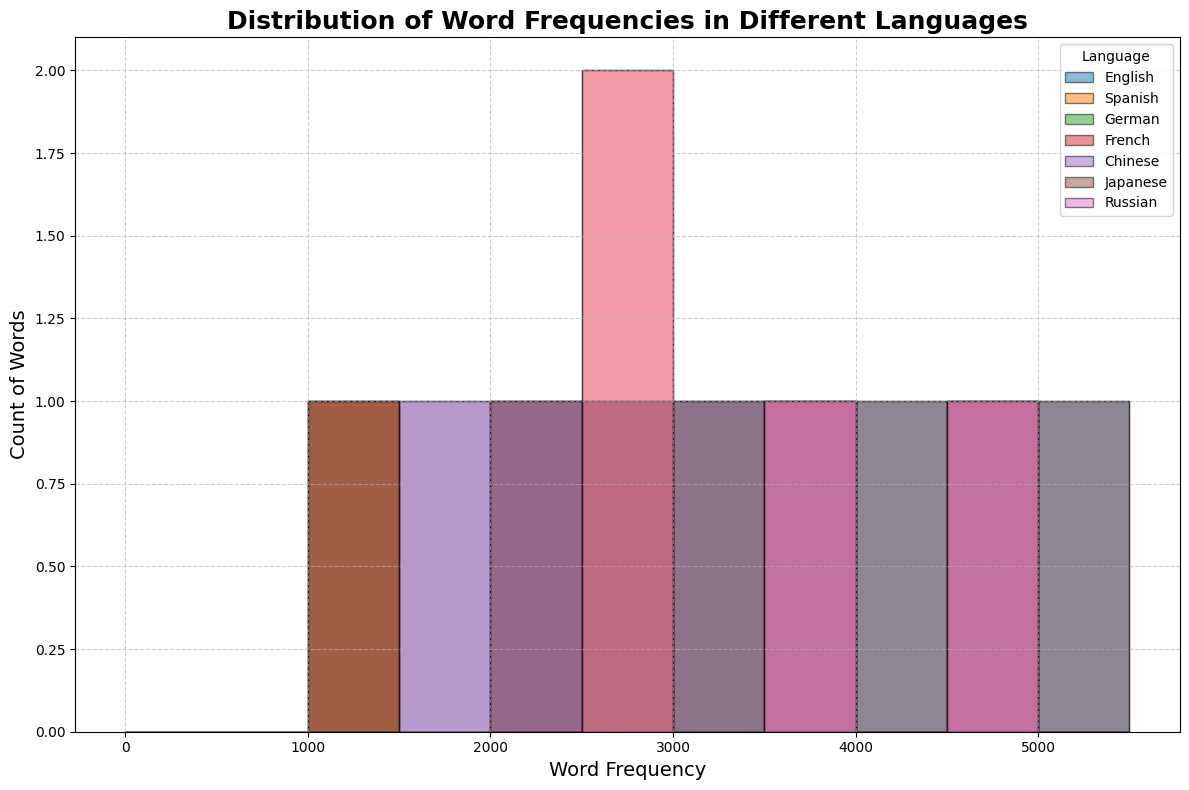Which language has the highest word frequency count in the dataset? By looking at the histogram, find the language with the tallest bar, indicating the highest total word frequency count.
Answer: Chinese How does the word frequency distribution in Japanese compare to that in English? Compare the height and spread of the histogram bars for Japanese and English. Ensure to note which language has more words in higher frequency ranges.
Answer: Japanese has higher frequency words than English Which language displays the widest range of word frequencies? Identify the language whose histogram bars stretch over the widest range of word frequencies.
Answer: Chinese Are there any languages with a similar word frequency range? Compare the histograms and find any languages that have overlapping frequency ranges and similar heights.
Answer: German and French have similar ranges Which language has the most words with a frequency over 5000? Count the number of bars representing words with frequencies greater than 5000 for each language.
Answer: Chinese Do Spanish and Russian have any words with frequencies between 3000 and 4000? Check the histogram bars for Spanish and Russian within the 3000 to 4000 frequency range.
Answer: Yes How does the frequency distribution for French and German compare? Compare the histograms for French and German by examining the height and frequency ranges of their bars.
Answer: French has slightly higher word frequencies overall than German What is the combined count of words with frequencies above 4000 for English and Japanese? Sum the count of words with frequencies over 4000 for both English and Japanese by looking at their respective histograms.
Answer: 6 Which language has more words with frequencies falling in the range 2000-3000? Compare the histograms for each language to see which has more bars within the 2000-3000 range.
Answer: Russian Are there any languages without word frequencies in certain ranges? Identify any gaps in the histograms where languages lack words within specific frequency ranges.
Answer: Some languages do not have words in the 500-1000 range 